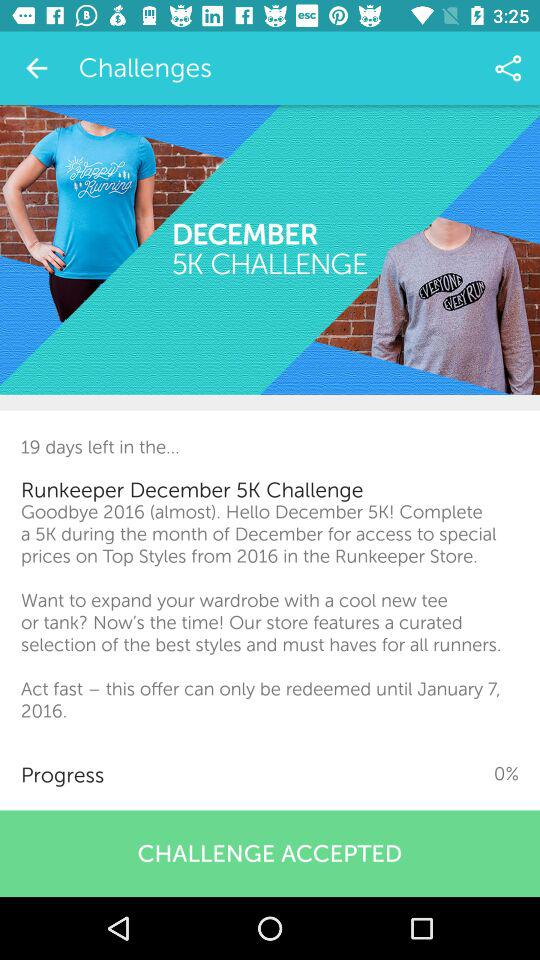How much progress has been made? There has been 0% progress made. 